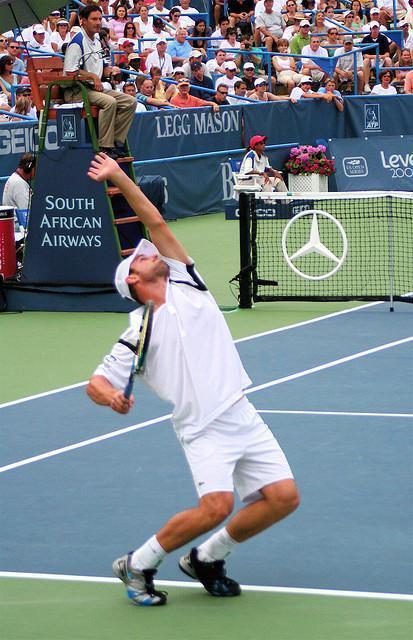How many people are in the picture?
Give a very brief answer. 3. 